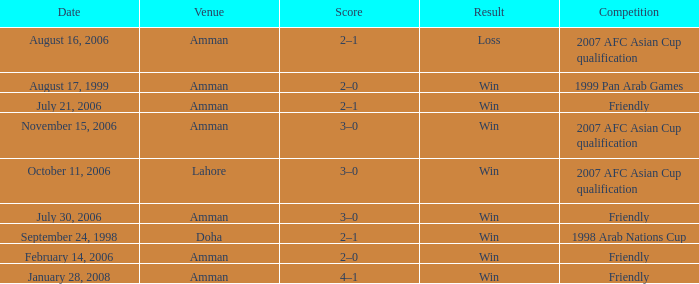Where did Ra'fat Ali play on August 17, 1999? Amman. 